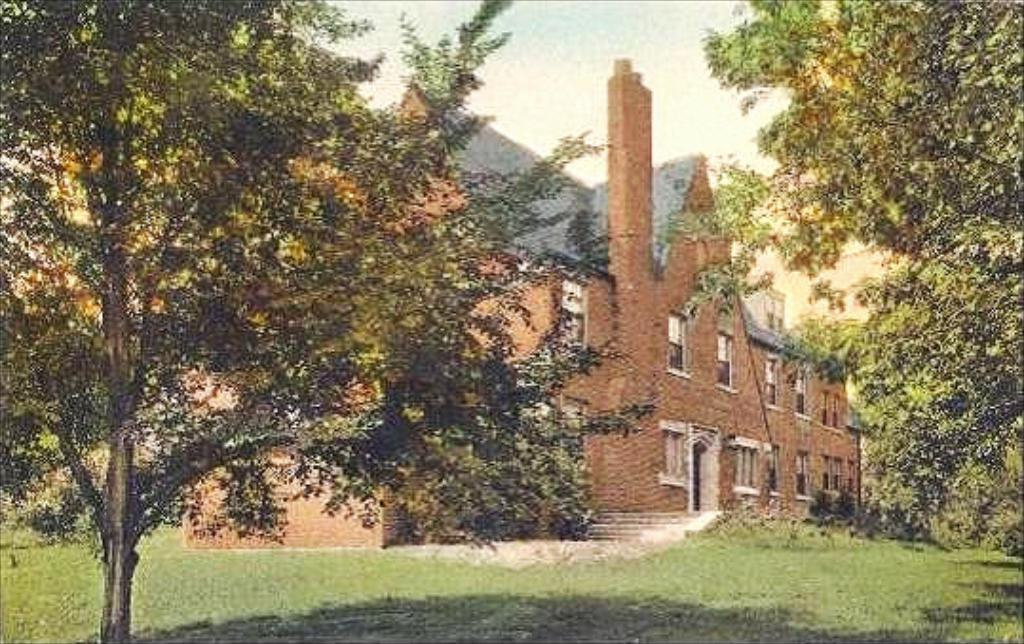What type of terrain is in the foreground of the image? There is grass land in the foreground of the image. What can be seen on either side of the grass land? There are trees on either side of the grass land. What structure is visible in the background of the image? There is a building visible in the background of the image. What is visible at the top of the image? The sky is visible at the top of the image. What type of poison is being used as bait in the image? There is no poison or bait present in the image. 